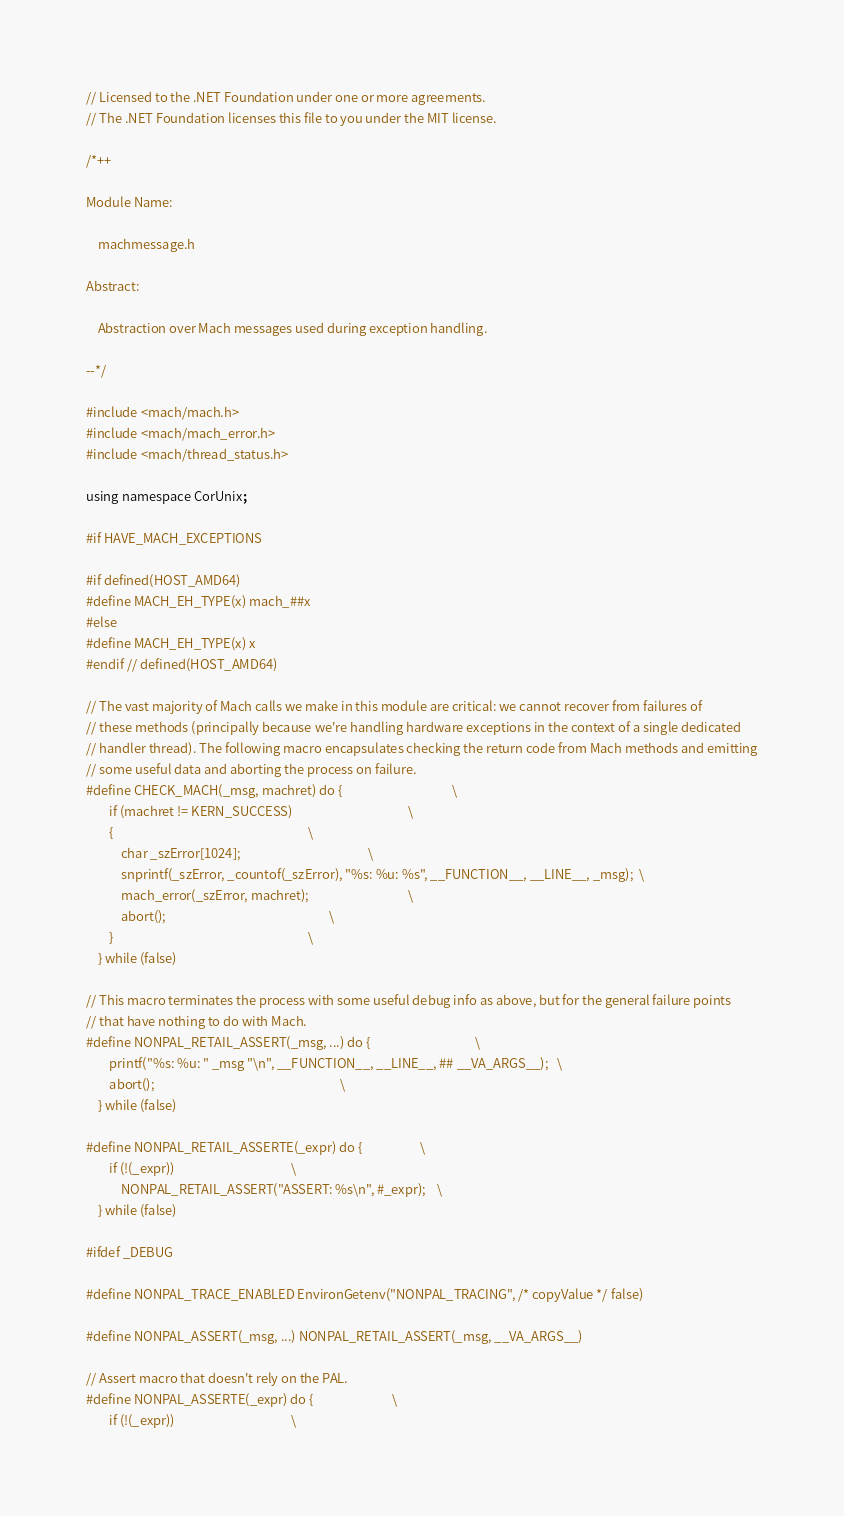<code> <loc_0><loc_0><loc_500><loc_500><_C_>// Licensed to the .NET Foundation under one or more agreements.
// The .NET Foundation licenses this file to you under the MIT license.

/*++

Module Name:

    machmessage.h

Abstract:

    Abstraction over Mach messages used during exception handling.

--*/

#include <mach/mach.h>
#include <mach/mach_error.h>
#include <mach/thread_status.h>

using namespace CorUnix;

#if HAVE_MACH_EXCEPTIONS

#if defined(HOST_AMD64)
#define MACH_EH_TYPE(x) mach_##x
#else
#define MACH_EH_TYPE(x) x
#endif // defined(HOST_AMD64)

// The vast majority of Mach calls we make in this module are critical: we cannot recover from failures of
// these methods (principally because we're handling hardware exceptions in the context of a single dedicated
// handler thread). The following macro encapsulates checking the return code from Mach methods and emitting
// some useful data and aborting the process on failure.
#define CHECK_MACH(_msg, machret) do {                                      \
        if (machret != KERN_SUCCESS)                                        \
        {                                                                   \
            char _szError[1024];                                            \
            snprintf(_szError, _countof(_szError), "%s: %u: %s", __FUNCTION__, __LINE__, _msg);  \
            mach_error(_szError, machret);                                  \
            abort();                                                        \
        }                                                                   \
    } while (false)

// This macro terminates the process with some useful debug info as above, but for the general failure points
// that have nothing to do with Mach.
#define NONPAL_RETAIL_ASSERT(_msg, ...) do {                                    \
        printf("%s: %u: " _msg "\n", __FUNCTION__, __LINE__, ## __VA_ARGS__);   \
        abort();                                                                \
    } while (false)

#define NONPAL_RETAIL_ASSERTE(_expr) do {                    \
        if (!(_expr))                                        \
            NONPAL_RETAIL_ASSERT("ASSERT: %s\n", #_expr);    \
    } while (false)

#ifdef _DEBUG

#define NONPAL_TRACE_ENABLED EnvironGetenv("NONPAL_TRACING", /* copyValue */ false)

#define NONPAL_ASSERT(_msg, ...) NONPAL_RETAIL_ASSERT(_msg, __VA_ARGS__)

// Assert macro that doesn't rely on the PAL.
#define NONPAL_ASSERTE(_expr) do {                           \
        if (!(_expr))                                        \</code> 